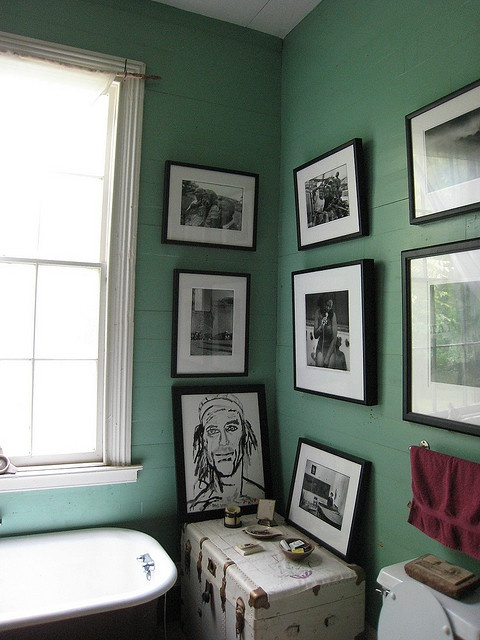Describe the objects in this image and their specific colors. I can see sink in black, white, gray, and darkgray tones and toilet in black, darkgray, and gray tones in this image. 